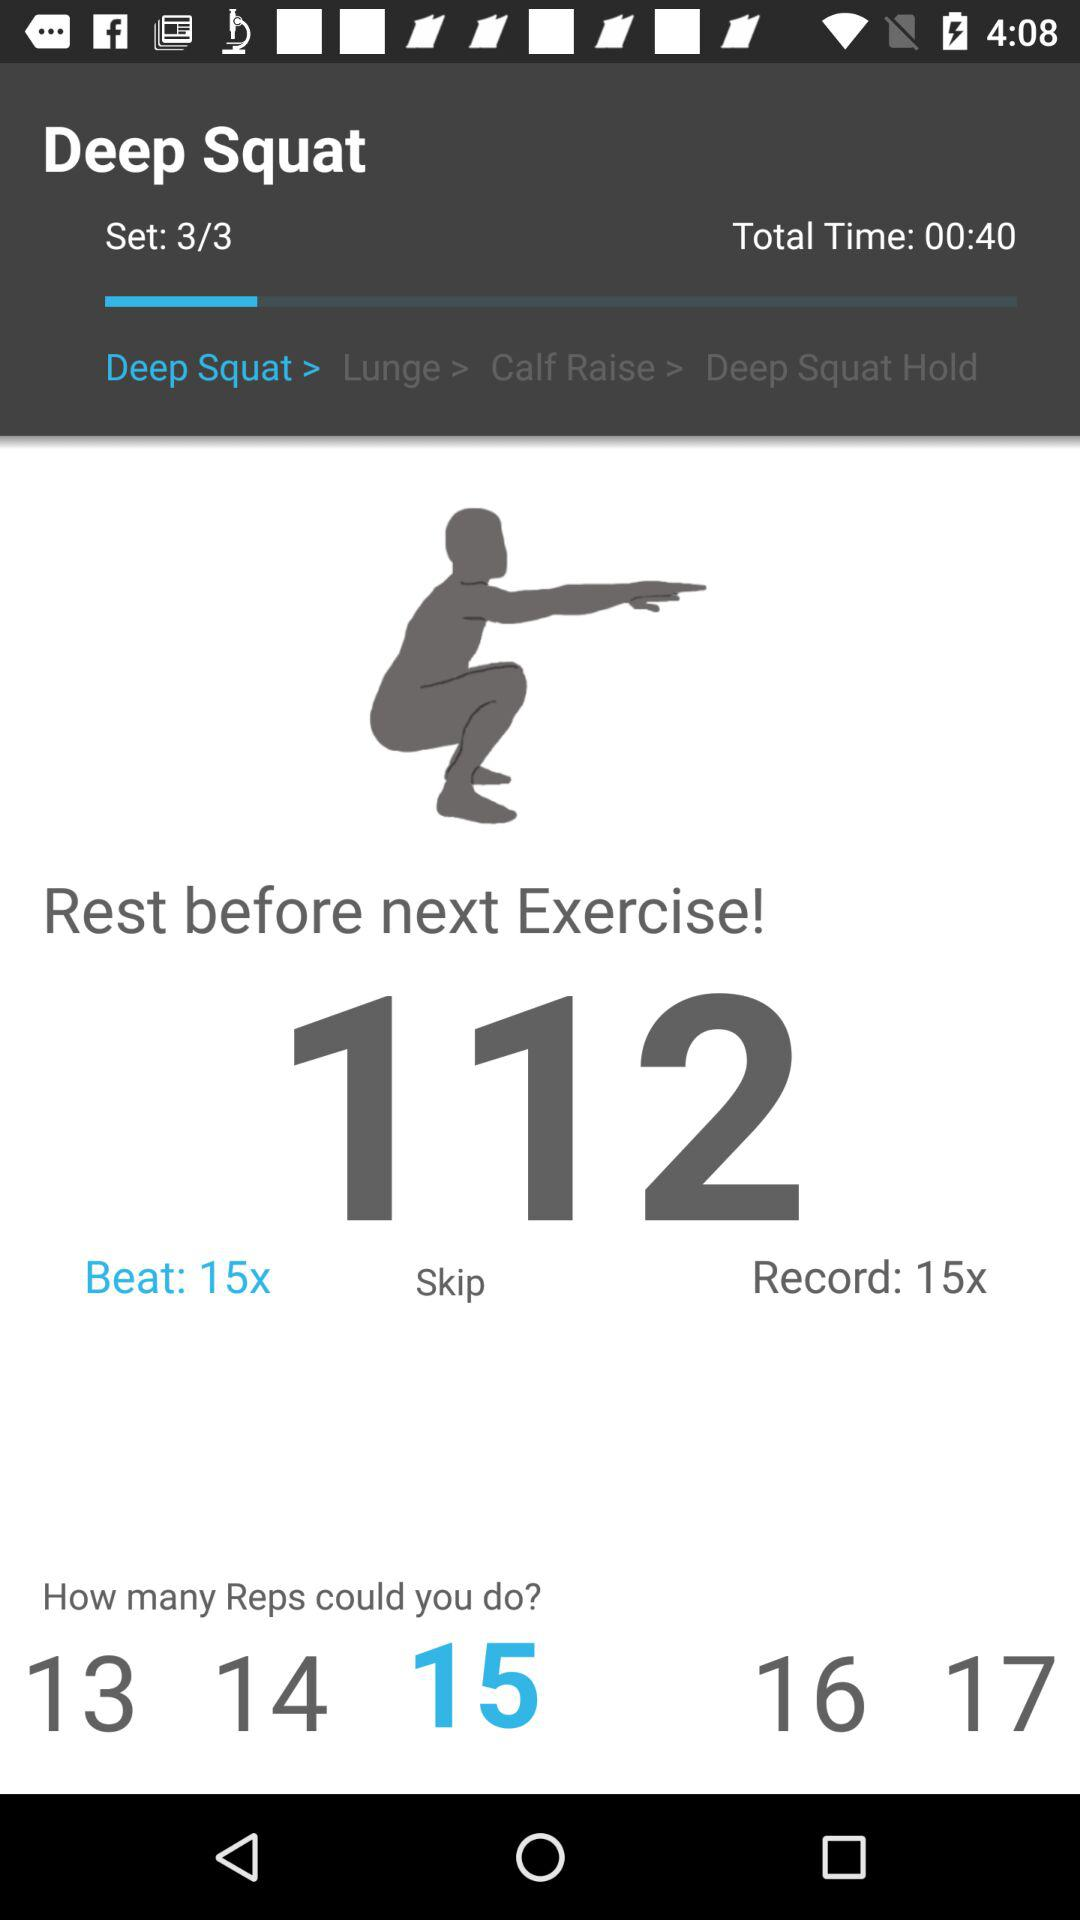How many sets have I completed?
Answer the question using a single word or phrase. 3 